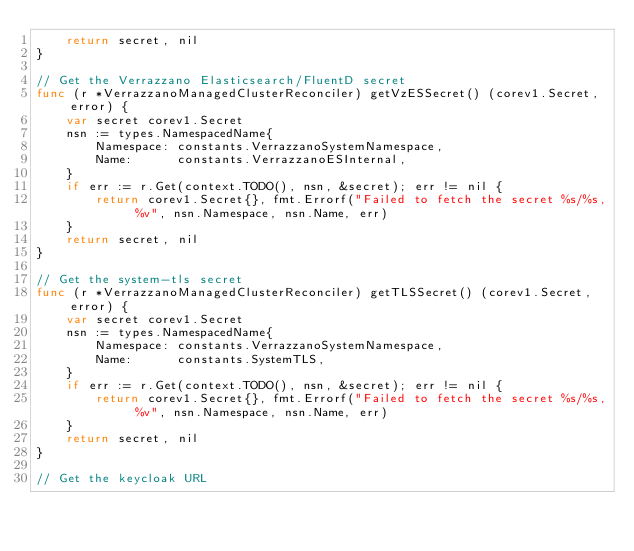<code> <loc_0><loc_0><loc_500><loc_500><_Go_>	return secret, nil
}

// Get the Verrazzano Elasticsearch/FluentD secret
func (r *VerrazzanoManagedClusterReconciler) getVzESSecret() (corev1.Secret, error) {
	var secret corev1.Secret
	nsn := types.NamespacedName{
		Namespace: constants.VerrazzanoSystemNamespace,
		Name:      constants.VerrazzanoESInternal,
	}
	if err := r.Get(context.TODO(), nsn, &secret); err != nil {
		return corev1.Secret{}, fmt.Errorf("Failed to fetch the secret %s/%s, %v", nsn.Namespace, nsn.Name, err)
	}
	return secret, nil
}

// Get the system-tls secret
func (r *VerrazzanoManagedClusterReconciler) getTLSSecret() (corev1.Secret, error) {
	var secret corev1.Secret
	nsn := types.NamespacedName{
		Namespace: constants.VerrazzanoSystemNamespace,
		Name:      constants.SystemTLS,
	}
	if err := r.Get(context.TODO(), nsn, &secret); err != nil {
		return corev1.Secret{}, fmt.Errorf("Failed to fetch the secret %s/%s, %v", nsn.Namespace, nsn.Name, err)
	}
	return secret, nil
}

// Get the keycloak URL</code> 